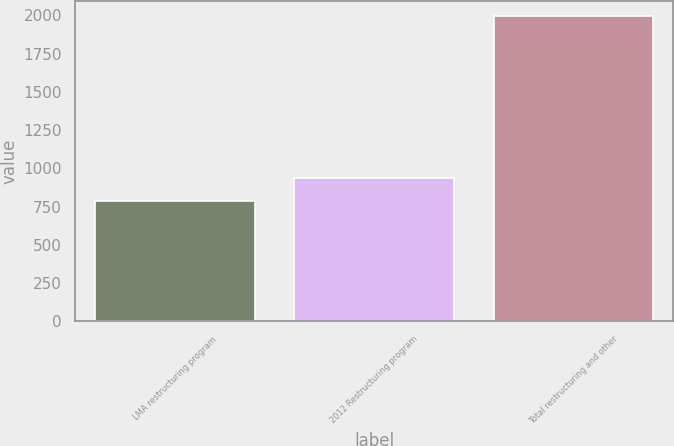Convert chart to OTSL. <chart><loc_0><loc_0><loc_500><loc_500><bar_chart><fcel>LMA restructuring program<fcel>2012 Restructuring program<fcel>Total restructuring and other<nl><fcel>788<fcel>935<fcel>1995<nl></chart> 